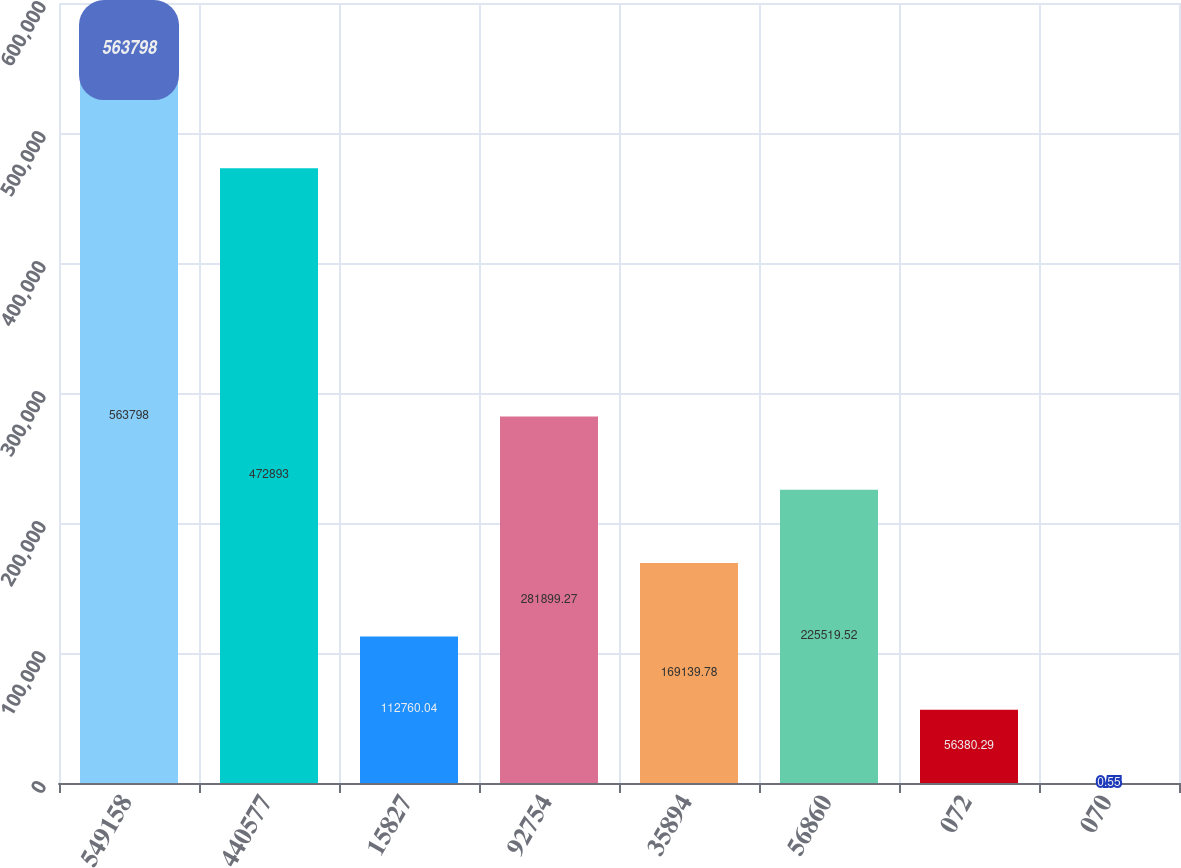<chart> <loc_0><loc_0><loc_500><loc_500><bar_chart><fcel>549158<fcel>440577<fcel>15827<fcel>92754<fcel>35894<fcel>56860<fcel>072<fcel>070<nl><fcel>563798<fcel>472893<fcel>112760<fcel>281899<fcel>169140<fcel>225520<fcel>56380.3<fcel>0.55<nl></chart> 